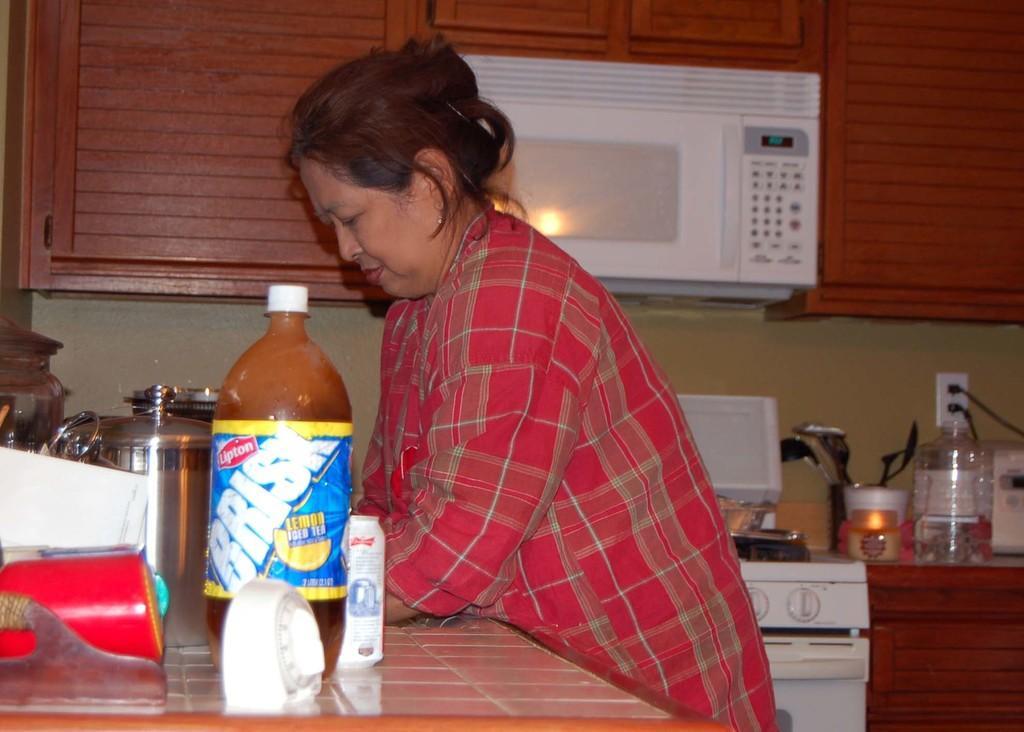Please provide a concise description of this image. there is a lady standing and lying on table where there is a bottle and some steel jars. Beside her there is a ovan and stove and tray with spoons and some jars. 